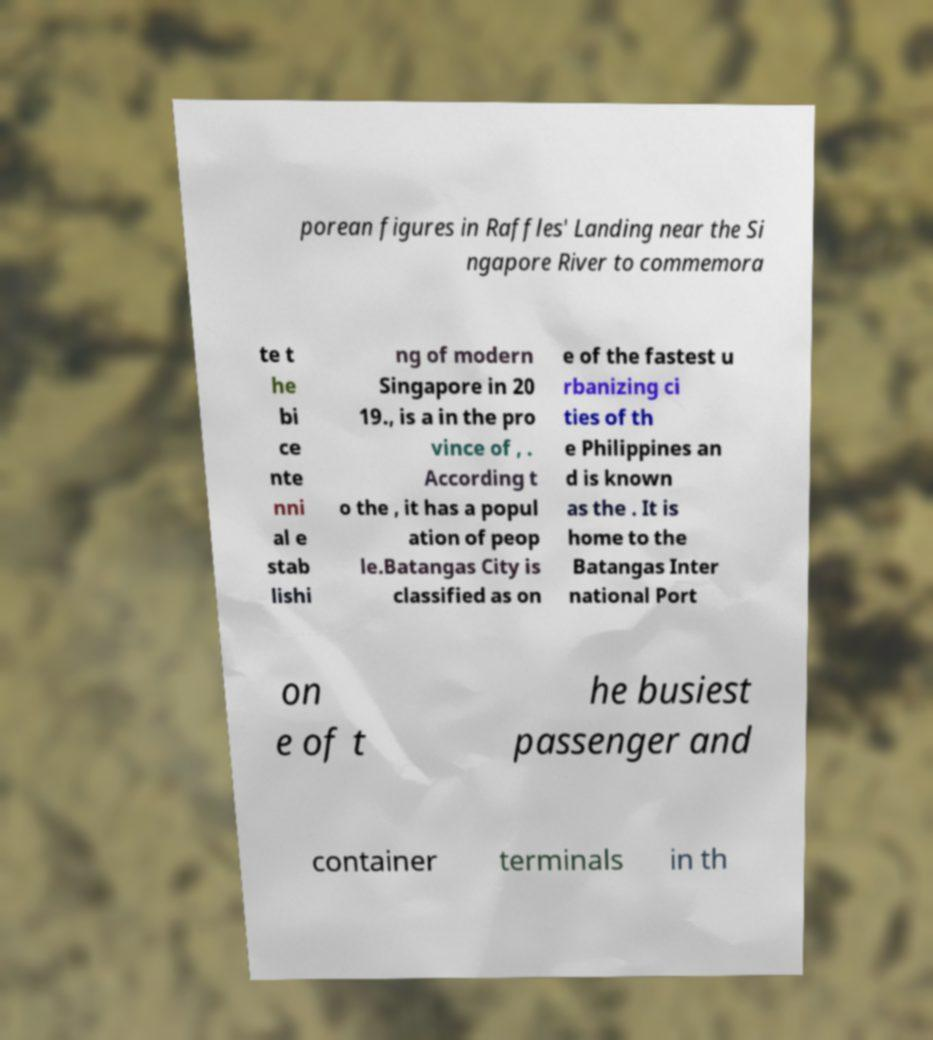I need the written content from this picture converted into text. Can you do that? porean figures in Raffles' Landing near the Si ngapore River to commemora te t he bi ce nte nni al e stab lishi ng of modern Singapore in 20 19., is a in the pro vince of , . According t o the , it has a popul ation of peop le.Batangas City is classified as on e of the fastest u rbanizing ci ties of th e Philippines an d is known as the . It is home to the Batangas Inter national Port on e of t he busiest passenger and container terminals in th 